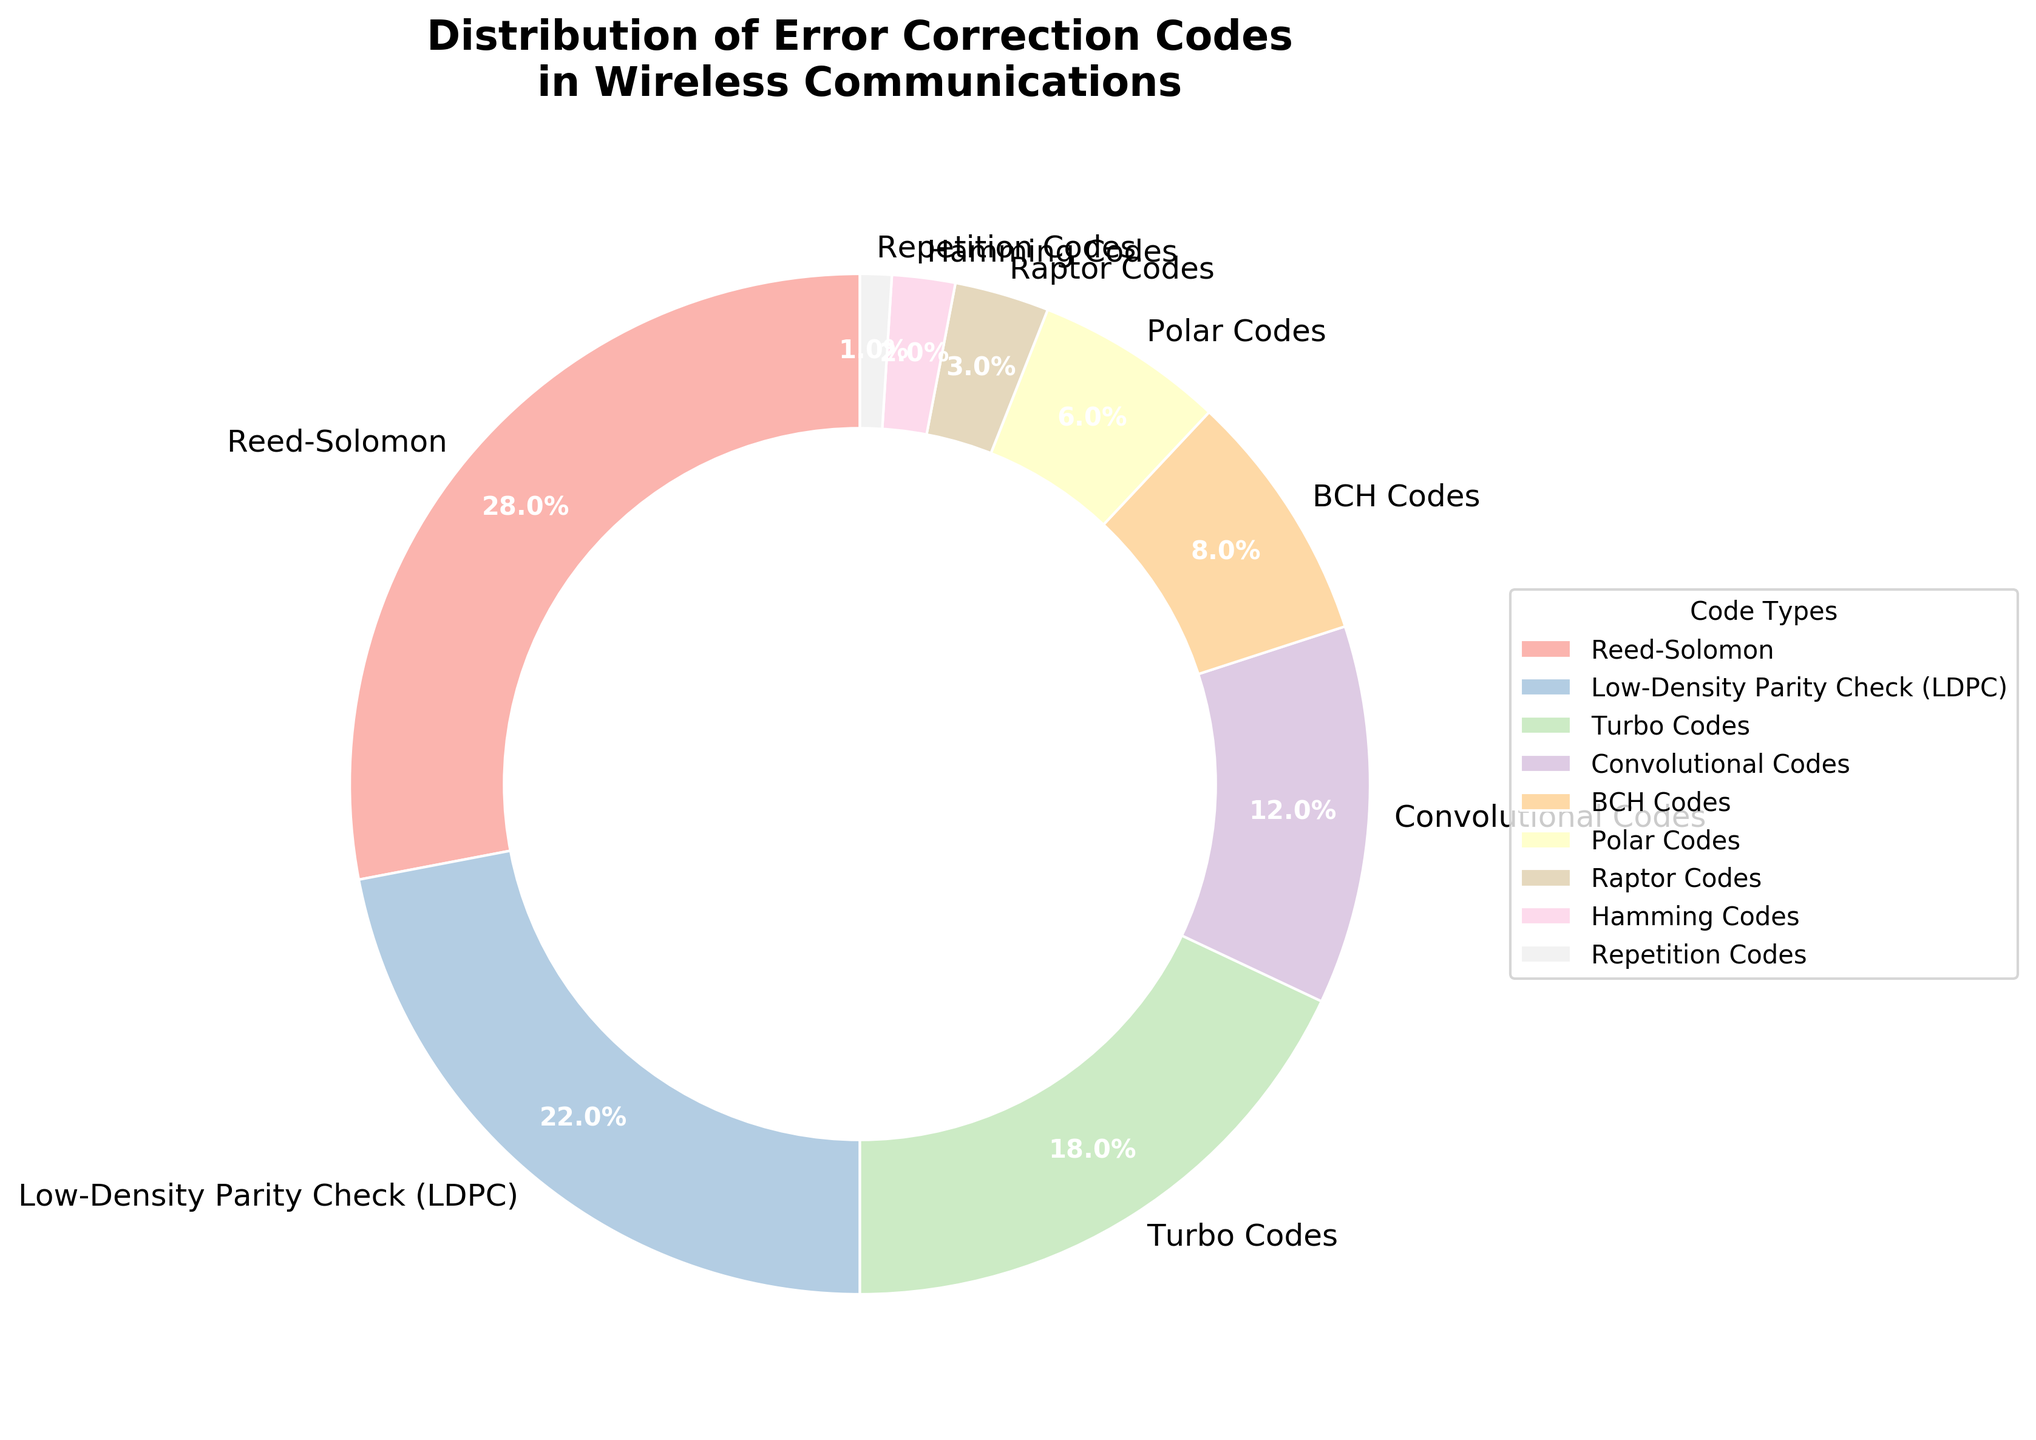What's the most frequently used error correction code in wireless communications? The pie chart shows the distribution of different error correction codes used in wireless communications. By looking at the size of each slice, the largest slice corresponds to the Reed-Solomon code.
Answer: Reed-Solomon Which code type has the second highest usage after Reed-Solomon? The pie chart shows the first largest slice belongs to Reed-Solomon and immediately next to it, the slice representing Low-Density Parity Check (LDPC) is the second largest.
Answer: Low-Density Parity Check (LDPC) What is the combined percentage of Convolutional Codes and BCH Codes? According to the pie chart, the Convolutional Codes have a percentage of 12% and BCH Codes have 8%. Adding these two values together, we get 12 + 8 = 20%.
Answer: 20% How does the usage of Polar Codes compare to that of Repetition Codes? By comparing the slices of the pie chart, Polar Codes account for 6% while Repetition Codes account for 1%. Therefore, Polar Codes are used more frequently than Repetition Codes.
Answer: Polar Codes are used more frequently Is the percentage of Turbo Codes greater than Low-Density Parity Check (LDPC) codes? From the pie chart, Turbo Codes have a percentage of 18%, while Low-Density Parity Check (LDPC) codes have a percentage of 22%. Since 18% is less than 22%, Turbo Codes are not greater than LDPC codes in usage.
Answer: No Which code types make up less than 5% of the distribution? By observing the pie chart and their respective percentages, only Raptor Codes, Hamming Codes, and Repetition Codes make up less than 5%, having 3%, 2%, and 1% respectively.
Answer: Raptor Codes, Hamming Codes, Repetition Codes What is the total percentage of the least three used codes in wireless communication? The chart shows that the least three used codes are Raptor Codes (3%), Hamming Codes (2%), and Repetition Codes (1%). Summing these gives 3 + 2 + 1 = 6%.
Answer: 6% Between Turtle Codes and Convolutional Codes, which has a smaller share and by how much? The pie chart shows that Turbo Codes have 18% and Convolutional Codes have 12%. The difference is 18 - 12 = 6%.
Answer: Convolutional Codes by 6% What portion of the chart is represented by Polar Codes visually? Judging by the pie chart, Polar Codes constitute a slice that is visually around 6% of the whole chart, which is relatively small compared to other segments, such as those of Reed-Solomon or LDPC.
Answer: 6% Describe the appearance of the slice representing Reed-Solomon codes in the chart. The slice for Reed-Solomon codes is the largest and appears to be located starting at the top right quadrant of the pie chart. It stands out both due to its size and its distinct color compared to other smaller segments.
Answer: Largest and distinct color 